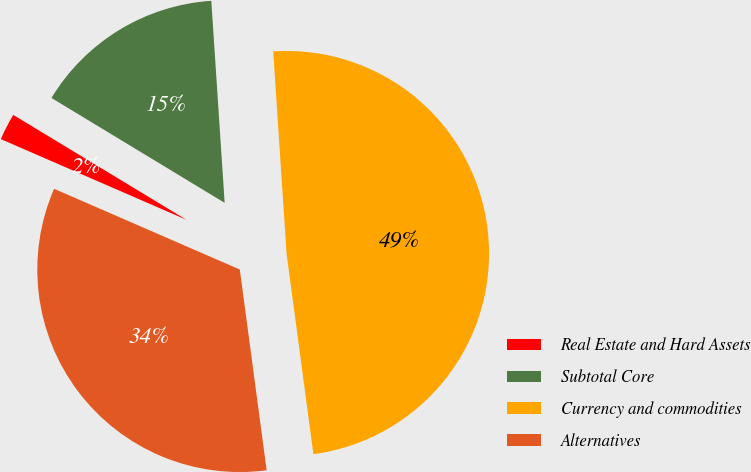Convert chart to OTSL. <chart><loc_0><loc_0><loc_500><loc_500><pie_chart><fcel>Real Estate and Hard Assets<fcel>Subtotal Core<fcel>Currency and commodities<fcel>Alternatives<nl><fcel>2.14%<fcel>15.28%<fcel>48.93%<fcel>33.64%<nl></chart> 